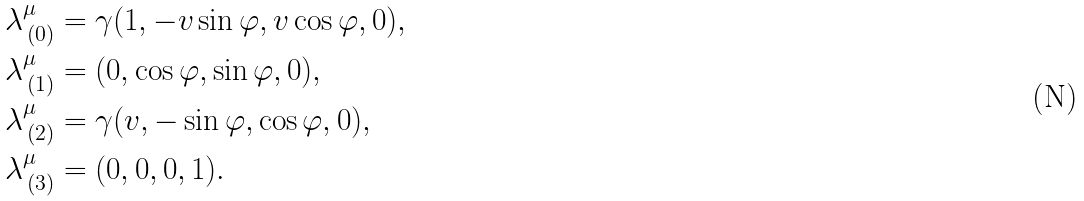Convert formula to latex. <formula><loc_0><loc_0><loc_500><loc_500>\lambda ^ { \mu } _ { \, ( 0 ) } & = \gamma ( 1 , - v \sin \varphi , v \cos \varphi , 0 ) , \\ \lambda ^ { \mu } _ { \, ( 1 ) } & = ( 0 , \cos \varphi , \sin \varphi , 0 ) , \\ \lambda ^ { \mu } _ { \, ( 2 ) } & = \gamma ( v , - \sin \varphi , \cos \varphi , 0 ) , \\ \lambda ^ { \mu } _ { \, ( 3 ) } & = ( 0 , 0 , 0 , 1 ) .</formula> 